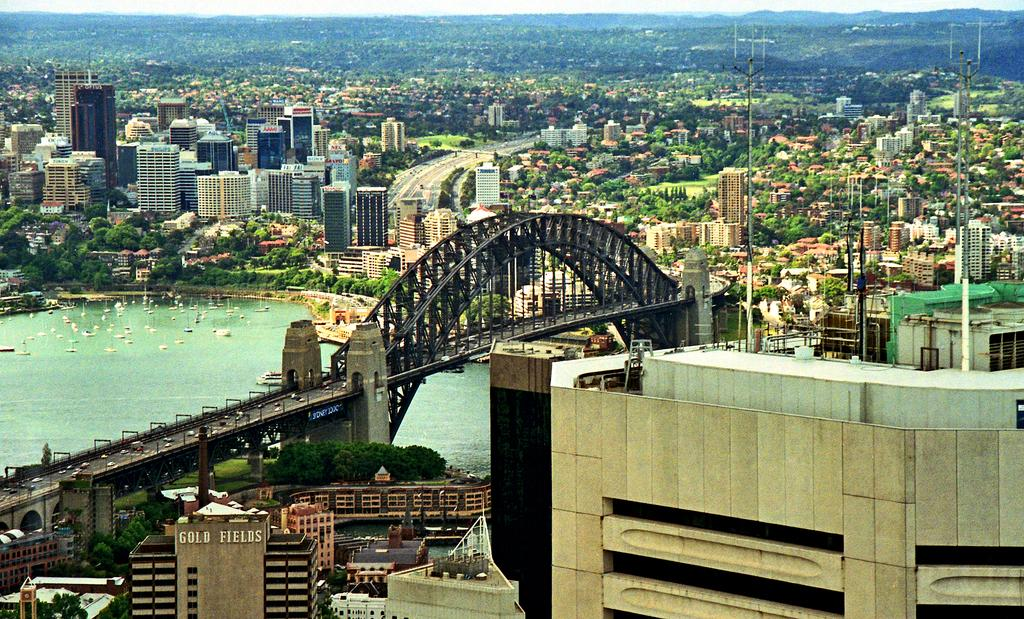What type of structures can be seen in the image? There are buildings in the image. What type of natural elements are present in the image? There are trees in the image. What type of infrastructure is visible in the image? There is a bridge in the image. What type of transportation is present in the image? There are vehicles in the image. What type of vertical structures are present in the image? There are poles in the image. What month is it in the image? The month cannot be determined from the image, as it does not contain any information about the time of year. How does the honey move around in the image? There is no honey present in the image, so it cannot be determined how it might move around. 